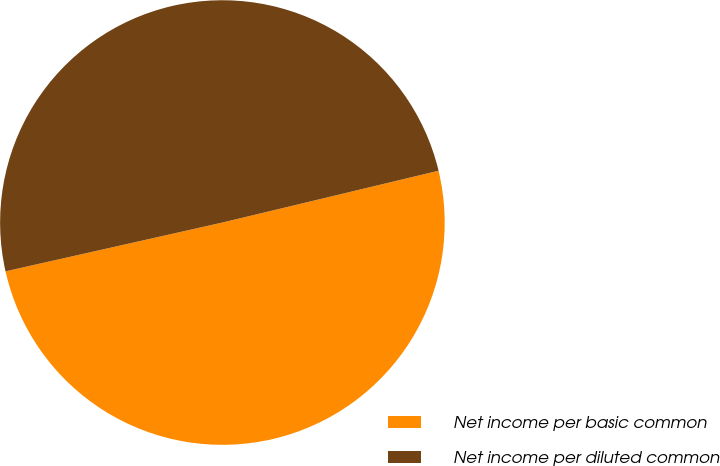Convert chart to OTSL. <chart><loc_0><loc_0><loc_500><loc_500><pie_chart><fcel>Net income per basic common<fcel>Net income per diluted common<nl><fcel>50.22%<fcel>49.78%<nl></chart> 